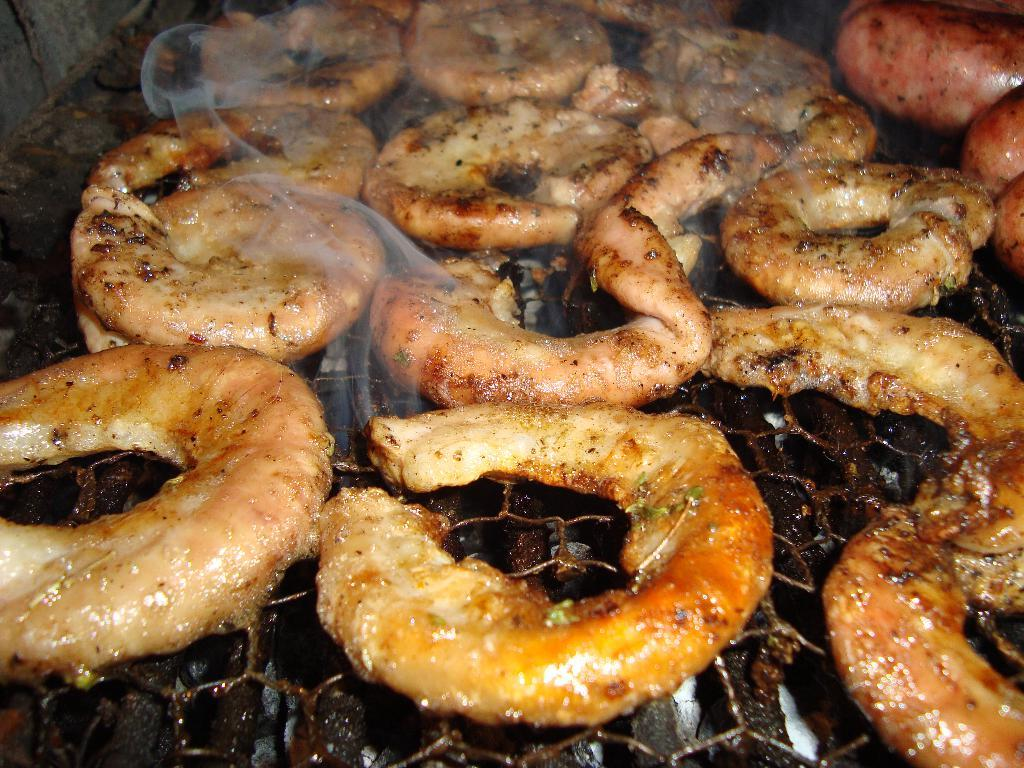What is being cooked on the grill in the image? There are food items on a grill in the image. What is under the grill to provide heat? There is coal under the grill. What is a noticeable effect on the food due to the cooking process? There is smoke on the food. How many people are present in the crowd in the image? There is no crowd present in the image; it features food items on a grill with coal underneath and smoke on the food. What type of test is being conducted on the food in the image? There is no test being conducted on the food in the image; it is simply being cooked on a grill. 